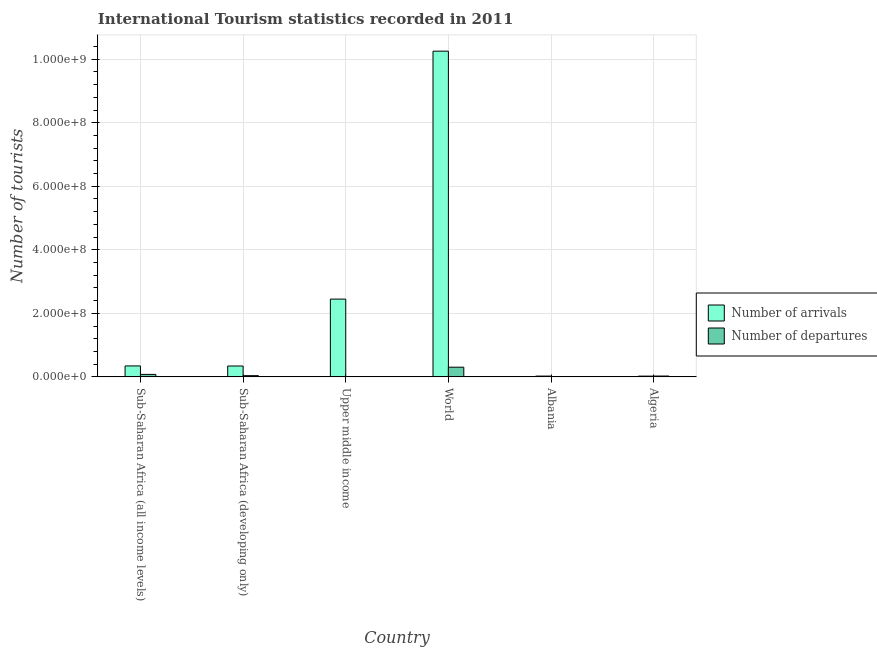How many groups of bars are there?
Your answer should be compact. 6. Are the number of bars per tick equal to the number of legend labels?
Your response must be concise. Yes. How many bars are there on the 3rd tick from the left?
Provide a succinct answer. 2. How many bars are there on the 3rd tick from the right?
Your answer should be very brief. 2. What is the label of the 1st group of bars from the left?
Provide a succinct answer. Sub-Saharan Africa (all income levels). What is the number of tourist departures in Sub-Saharan Africa (all income levels)?
Your answer should be very brief. 7.80e+06. Across all countries, what is the maximum number of tourist departures?
Your response must be concise. 3.04e+07. Across all countries, what is the minimum number of tourist departures?
Your answer should be compact. 7.60e+04. In which country was the number of tourist arrivals maximum?
Offer a very short reply. World. In which country was the number of tourist departures minimum?
Give a very brief answer. Albania. What is the total number of tourist departures in the graph?
Ensure brevity in your answer.  4.55e+07. What is the difference between the number of tourist arrivals in Albania and that in Algeria?
Provide a succinct answer. 7.40e+04. What is the difference between the number of tourist arrivals in Upper middle income and the number of tourist departures in World?
Keep it short and to the point. 2.14e+08. What is the average number of tourist arrivals per country?
Make the answer very short. 2.24e+08. What is the difference between the number of tourist arrivals and number of tourist departures in Upper middle income?
Offer a terse response. 2.44e+08. What is the ratio of the number of tourist departures in Algeria to that in Upper middle income?
Give a very brief answer. 3.72. What is the difference between the highest and the second highest number of tourist departures?
Provide a succinct answer. 2.26e+07. What is the difference between the highest and the lowest number of tourist arrivals?
Your response must be concise. 1.02e+09. What does the 1st bar from the left in Upper middle income represents?
Your answer should be very brief. Number of arrivals. What does the 2nd bar from the right in Upper middle income represents?
Keep it short and to the point. Number of arrivals. Are all the bars in the graph horizontal?
Offer a terse response. No. What is the difference between two consecutive major ticks on the Y-axis?
Keep it short and to the point. 2.00e+08. Does the graph contain any zero values?
Provide a short and direct response. No. Does the graph contain grids?
Ensure brevity in your answer.  Yes. What is the title of the graph?
Ensure brevity in your answer.  International Tourism statistics recorded in 2011. Does "Investment in Telecom" appear as one of the legend labels in the graph?
Your response must be concise. No. What is the label or title of the X-axis?
Offer a terse response. Country. What is the label or title of the Y-axis?
Keep it short and to the point. Number of tourists. What is the Number of tourists of Number of arrivals in Sub-Saharan Africa (all income levels)?
Give a very brief answer. 3.44e+07. What is the Number of tourists in Number of departures in Sub-Saharan Africa (all income levels)?
Offer a terse response. 7.80e+06. What is the Number of tourists in Number of arrivals in Sub-Saharan Africa (developing only)?
Offer a terse response. 3.42e+07. What is the Number of tourists in Number of departures in Sub-Saharan Africa (developing only)?
Offer a very short reply. 3.80e+06. What is the Number of tourists in Number of arrivals in Upper middle income?
Offer a terse response. 2.45e+08. What is the Number of tourists of Number of departures in Upper middle income?
Keep it short and to the point. 7.10e+05. What is the Number of tourists of Number of arrivals in World?
Your answer should be compact. 1.03e+09. What is the Number of tourists in Number of departures in World?
Keep it short and to the point. 3.04e+07. What is the Number of tourists of Number of arrivals in Albania?
Offer a terse response. 2.47e+06. What is the Number of tourists in Number of departures in Albania?
Your response must be concise. 7.60e+04. What is the Number of tourists in Number of arrivals in Algeria?
Offer a very short reply. 2.40e+06. What is the Number of tourists in Number of departures in Algeria?
Offer a terse response. 2.64e+06. Across all countries, what is the maximum Number of tourists in Number of arrivals?
Give a very brief answer. 1.03e+09. Across all countries, what is the maximum Number of tourists in Number of departures?
Keep it short and to the point. 3.04e+07. Across all countries, what is the minimum Number of tourists of Number of arrivals?
Offer a terse response. 2.40e+06. Across all countries, what is the minimum Number of tourists of Number of departures?
Give a very brief answer. 7.60e+04. What is the total Number of tourists of Number of arrivals in the graph?
Offer a very short reply. 1.34e+09. What is the total Number of tourists of Number of departures in the graph?
Your response must be concise. 4.55e+07. What is the difference between the Number of tourists in Number of arrivals in Sub-Saharan Africa (all income levels) and that in Sub-Saharan Africa (developing only)?
Your answer should be very brief. 2.34e+05. What is the difference between the Number of tourists in Number of departures in Sub-Saharan Africa (all income levels) and that in Sub-Saharan Africa (developing only)?
Keep it short and to the point. 4.00e+06. What is the difference between the Number of tourists of Number of arrivals in Sub-Saharan Africa (all income levels) and that in Upper middle income?
Provide a succinct answer. -2.10e+08. What is the difference between the Number of tourists of Number of departures in Sub-Saharan Africa (all income levels) and that in Upper middle income?
Provide a short and direct response. 7.10e+06. What is the difference between the Number of tourists of Number of arrivals in Sub-Saharan Africa (all income levels) and that in World?
Offer a terse response. -9.91e+08. What is the difference between the Number of tourists of Number of departures in Sub-Saharan Africa (all income levels) and that in World?
Your response must be concise. -2.26e+07. What is the difference between the Number of tourists of Number of arrivals in Sub-Saharan Africa (all income levels) and that in Albania?
Provide a short and direct response. 3.20e+07. What is the difference between the Number of tourists of Number of departures in Sub-Saharan Africa (all income levels) and that in Albania?
Provide a short and direct response. 7.73e+06. What is the difference between the Number of tourists of Number of arrivals in Sub-Saharan Africa (all income levels) and that in Algeria?
Keep it short and to the point. 3.20e+07. What is the difference between the Number of tourists in Number of departures in Sub-Saharan Africa (all income levels) and that in Algeria?
Give a very brief answer. 5.17e+06. What is the difference between the Number of tourists in Number of arrivals in Sub-Saharan Africa (developing only) and that in Upper middle income?
Offer a terse response. -2.11e+08. What is the difference between the Number of tourists in Number of departures in Sub-Saharan Africa (developing only) and that in Upper middle income?
Offer a very short reply. 3.09e+06. What is the difference between the Number of tourists of Number of arrivals in Sub-Saharan Africa (developing only) and that in World?
Provide a succinct answer. -9.91e+08. What is the difference between the Number of tourists in Number of departures in Sub-Saharan Africa (developing only) and that in World?
Provide a short and direct response. -2.66e+07. What is the difference between the Number of tourists of Number of arrivals in Sub-Saharan Africa (developing only) and that in Albania?
Offer a terse response. 3.17e+07. What is the difference between the Number of tourists of Number of departures in Sub-Saharan Africa (developing only) and that in Albania?
Ensure brevity in your answer.  3.73e+06. What is the difference between the Number of tourists of Number of arrivals in Sub-Saharan Africa (developing only) and that in Algeria?
Provide a short and direct response. 3.18e+07. What is the difference between the Number of tourists of Number of departures in Sub-Saharan Africa (developing only) and that in Algeria?
Provide a short and direct response. 1.16e+06. What is the difference between the Number of tourists in Number of arrivals in Upper middle income and that in World?
Keep it short and to the point. -7.80e+08. What is the difference between the Number of tourists in Number of departures in Upper middle income and that in World?
Your response must be concise. -2.97e+07. What is the difference between the Number of tourists in Number of arrivals in Upper middle income and that in Albania?
Offer a terse response. 2.42e+08. What is the difference between the Number of tourists of Number of departures in Upper middle income and that in Albania?
Make the answer very short. 6.34e+05. What is the difference between the Number of tourists in Number of arrivals in Upper middle income and that in Algeria?
Ensure brevity in your answer.  2.42e+08. What is the difference between the Number of tourists of Number of departures in Upper middle income and that in Algeria?
Your answer should be compact. -1.93e+06. What is the difference between the Number of tourists in Number of arrivals in World and that in Albania?
Keep it short and to the point. 1.02e+09. What is the difference between the Number of tourists in Number of departures in World and that in Albania?
Offer a very short reply. 3.04e+07. What is the difference between the Number of tourists of Number of arrivals in World and that in Algeria?
Provide a short and direct response. 1.02e+09. What is the difference between the Number of tourists in Number of departures in World and that in Algeria?
Give a very brief answer. 2.78e+07. What is the difference between the Number of tourists of Number of arrivals in Albania and that in Algeria?
Ensure brevity in your answer.  7.40e+04. What is the difference between the Number of tourists in Number of departures in Albania and that in Algeria?
Offer a very short reply. -2.56e+06. What is the difference between the Number of tourists of Number of arrivals in Sub-Saharan Africa (all income levels) and the Number of tourists of Number of departures in Sub-Saharan Africa (developing only)?
Ensure brevity in your answer.  3.06e+07. What is the difference between the Number of tourists of Number of arrivals in Sub-Saharan Africa (all income levels) and the Number of tourists of Number of departures in Upper middle income?
Your answer should be very brief. 3.37e+07. What is the difference between the Number of tourists of Number of arrivals in Sub-Saharan Africa (all income levels) and the Number of tourists of Number of departures in World?
Your answer should be very brief. 3.99e+06. What is the difference between the Number of tourists in Number of arrivals in Sub-Saharan Africa (all income levels) and the Number of tourists in Number of departures in Albania?
Your answer should be very brief. 3.44e+07. What is the difference between the Number of tourists in Number of arrivals in Sub-Saharan Africa (all income levels) and the Number of tourists in Number of departures in Algeria?
Give a very brief answer. 3.18e+07. What is the difference between the Number of tourists in Number of arrivals in Sub-Saharan Africa (developing only) and the Number of tourists in Number of departures in Upper middle income?
Make the answer very short. 3.35e+07. What is the difference between the Number of tourists in Number of arrivals in Sub-Saharan Africa (developing only) and the Number of tourists in Number of departures in World?
Your answer should be compact. 3.75e+06. What is the difference between the Number of tourists of Number of arrivals in Sub-Saharan Africa (developing only) and the Number of tourists of Number of departures in Albania?
Offer a very short reply. 3.41e+07. What is the difference between the Number of tourists in Number of arrivals in Sub-Saharan Africa (developing only) and the Number of tourists in Number of departures in Algeria?
Offer a terse response. 3.16e+07. What is the difference between the Number of tourists in Number of arrivals in Upper middle income and the Number of tourists in Number of departures in World?
Give a very brief answer. 2.14e+08. What is the difference between the Number of tourists in Number of arrivals in Upper middle income and the Number of tourists in Number of departures in Albania?
Provide a succinct answer. 2.45e+08. What is the difference between the Number of tourists of Number of arrivals in Upper middle income and the Number of tourists of Number of departures in Algeria?
Provide a succinct answer. 2.42e+08. What is the difference between the Number of tourists of Number of arrivals in World and the Number of tourists of Number of departures in Albania?
Keep it short and to the point. 1.03e+09. What is the difference between the Number of tourists of Number of arrivals in World and the Number of tourists of Number of departures in Algeria?
Offer a terse response. 1.02e+09. What is the difference between the Number of tourists of Number of arrivals in Albania and the Number of tourists of Number of departures in Algeria?
Your answer should be very brief. -1.69e+05. What is the average Number of tourists in Number of arrivals per country?
Your response must be concise. 2.24e+08. What is the average Number of tourists of Number of departures per country?
Offer a very short reply. 7.58e+06. What is the difference between the Number of tourists in Number of arrivals and Number of tourists in Number of departures in Sub-Saharan Africa (all income levels)?
Provide a succinct answer. 2.66e+07. What is the difference between the Number of tourists of Number of arrivals and Number of tourists of Number of departures in Sub-Saharan Africa (developing only)?
Provide a short and direct response. 3.04e+07. What is the difference between the Number of tourists of Number of arrivals and Number of tourists of Number of departures in Upper middle income?
Offer a very short reply. 2.44e+08. What is the difference between the Number of tourists of Number of arrivals and Number of tourists of Number of departures in World?
Your response must be concise. 9.95e+08. What is the difference between the Number of tourists of Number of arrivals and Number of tourists of Number of departures in Albania?
Ensure brevity in your answer.  2.39e+06. What is the difference between the Number of tourists in Number of arrivals and Number of tourists in Number of departures in Algeria?
Keep it short and to the point. -2.43e+05. What is the ratio of the Number of tourists of Number of arrivals in Sub-Saharan Africa (all income levels) to that in Sub-Saharan Africa (developing only)?
Your answer should be compact. 1.01. What is the ratio of the Number of tourists of Number of departures in Sub-Saharan Africa (all income levels) to that in Sub-Saharan Africa (developing only)?
Your answer should be compact. 2.05. What is the ratio of the Number of tourists in Number of arrivals in Sub-Saharan Africa (all income levels) to that in Upper middle income?
Provide a succinct answer. 0.14. What is the ratio of the Number of tourists of Number of departures in Sub-Saharan Africa (all income levels) to that in Upper middle income?
Ensure brevity in your answer.  10.99. What is the ratio of the Number of tourists in Number of arrivals in Sub-Saharan Africa (all income levels) to that in World?
Offer a terse response. 0.03. What is the ratio of the Number of tourists in Number of departures in Sub-Saharan Africa (all income levels) to that in World?
Give a very brief answer. 0.26. What is the ratio of the Number of tourists of Number of arrivals in Sub-Saharan Africa (all income levels) to that in Albania?
Your response must be concise. 13.95. What is the ratio of the Number of tourists in Number of departures in Sub-Saharan Africa (all income levels) to that in Albania?
Ensure brevity in your answer.  102.7. What is the ratio of the Number of tourists in Number of arrivals in Sub-Saharan Africa (all income levels) to that in Algeria?
Provide a succinct answer. 14.38. What is the ratio of the Number of tourists in Number of departures in Sub-Saharan Africa (all income levels) to that in Algeria?
Provide a succinct answer. 2.96. What is the ratio of the Number of tourists of Number of arrivals in Sub-Saharan Africa (developing only) to that in Upper middle income?
Offer a very short reply. 0.14. What is the ratio of the Number of tourists in Number of departures in Sub-Saharan Africa (developing only) to that in Upper middle income?
Give a very brief answer. 5.36. What is the ratio of the Number of tourists of Number of arrivals in Sub-Saharan Africa (developing only) to that in World?
Provide a short and direct response. 0.03. What is the ratio of the Number of tourists in Number of departures in Sub-Saharan Africa (developing only) to that in World?
Provide a succinct answer. 0.12. What is the ratio of the Number of tourists in Number of arrivals in Sub-Saharan Africa (developing only) to that in Albania?
Keep it short and to the point. 13.85. What is the ratio of the Number of tourists in Number of departures in Sub-Saharan Africa (developing only) to that in Albania?
Your response must be concise. 50.04. What is the ratio of the Number of tourists in Number of arrivals in Sub-Saharan Africa (developing only) to that in Algeria?
Your answer should be compact. 14.28. What is the ratio of the Number of tourists of Number of departures in Sub-Saharan Africa (developing only) to that in Algeria?
Provide a short and direct response. 1.44. What is the ratio of the Number of tourists of Number of arrivals in Upper middle income to that in World?
Give a very brief answer. 0.24. What is the ratio of the Number of tourists of Number of departures in Upper middle income to that in World?
Offer a very short reply. 0.02. What is the ratio of the Number of tourists in Number of arrivals in Upper middle income to that in Albania?
Provide a short and direct response. 99.16. What is the ratio of the Number of tourists of Number of departures in Upper middle income to that in Albania?
Offer a terse response. 9.34. What is the ratio of the Number of tourists in Number of arrivals in Upper middle income to that in Algeria?
Offer a very short reply. 102.23. What is the ratio of the Number of tourists in Number of departures in Upper middle income to that in Algeria?
Your answer should be compact. 0.27. What is the ratio of the Number of tourists in Number of arrivals in World to that in Albania?
Your answer should be compact. 415.27. What is the ratio of the Number of tourists of Number of departures in World to that in Albania?
Give a very brief answer. 400.66. What is the ratio of the Number of tourists of Number of arrivals in World to that in Algeria?
Provide a short and direct response. 428.1. What is the ratio of the Number of tourists in Number of departures in World to that in Algeria?
Give a very brief answer. 11.54. What is the ratio of the Number of tourists in Number of arrivals in Albania to that in Algeria?
Provide a short and direct response. 1.03. What is the ratio of the Number of tourists of Number of departures in Albania to that in Algeria?
Ensure brevity in your answer.  0.03. What is the difference between the highest and the second highest Number of tourists of Number of arrivals?
Provide a short and direct response. 7.80e+08. What is the difference between the highest and the second highest Number of tourists of Number of departures?
Give a very brief answer. 2.26e+07. What is the difference between the highest and the lowest Number of tourists in Number of arrivals?
Give a very brief answer. 1.02e+09. What is the difference between the highest and the lowest Number of tourists in Number of departures?
Offer a terse response. 3.04e+07. 